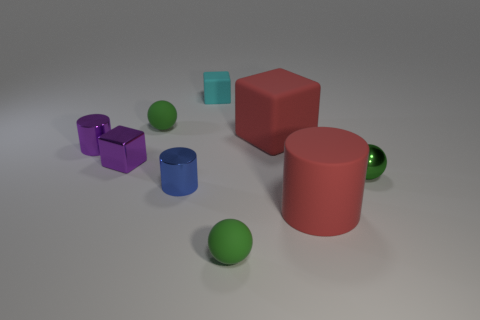Subtract all tiny cylinders. How many cylinders are left? 1 Subtract 1 cylinders. How many cylinders are left? 2 Add 1 big red matte things. How many objects exist? 10 Subtract all cylinders. How many objects are left? 6 Subtract 0 green cylinders. How many objects are left? 9 Subtract all brown matte balls. Subtract all large red cubes. How many objects are left? 8 Add 7 purple metallic things. How many purple metallic things are left? 9 Add 2 green rubber things. How many green rubber things exist? 4 